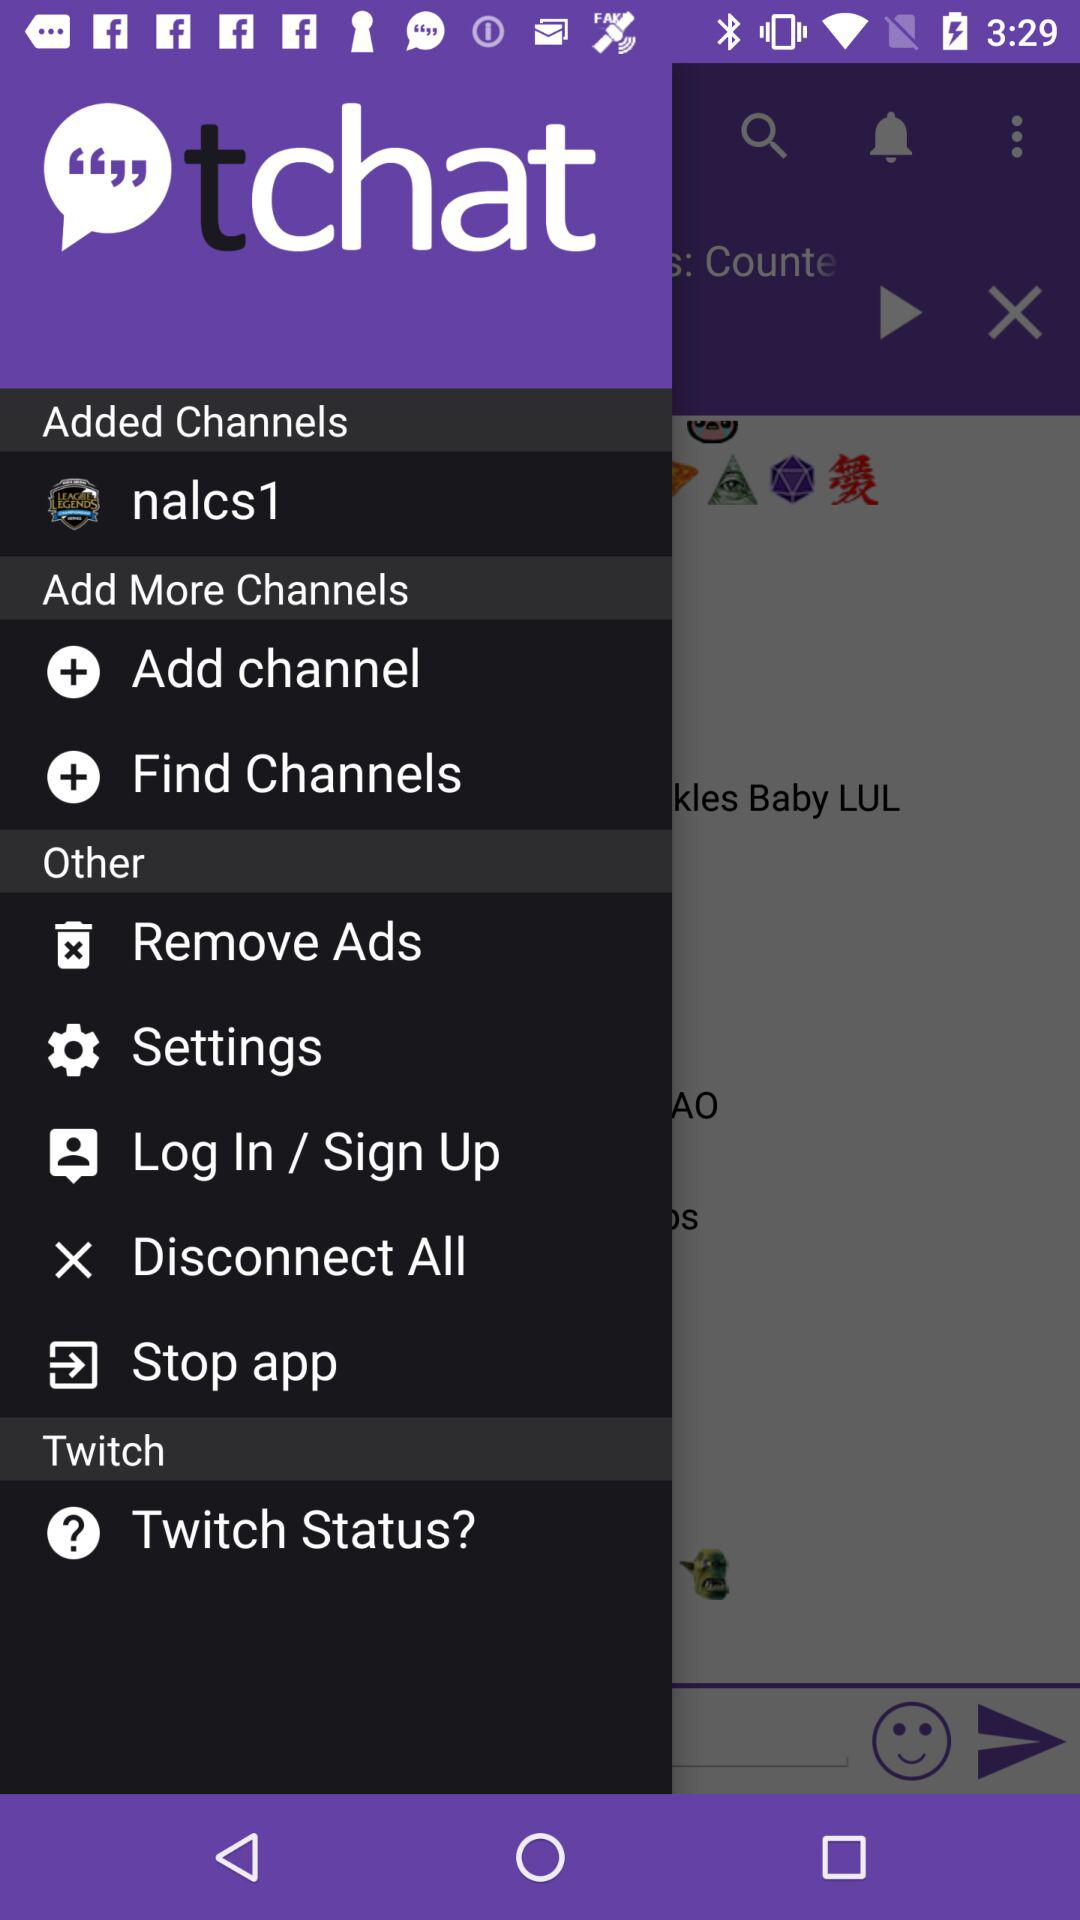What is the name of the application? The name of the application is "tchat". 